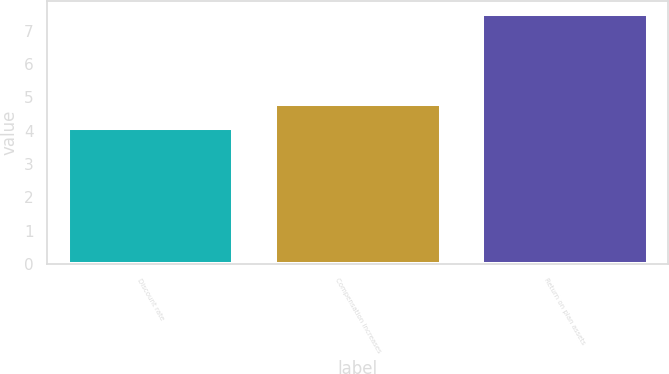<chart> <loc_0><loc_0><loc_500><loc_500><bar_chart><fcel>Discount rate<fcel>Compensation increases<fcel>Return on plan assets<nl><fcel>4.07<fcel>4.79<fcel>7.5<nl></chart> 